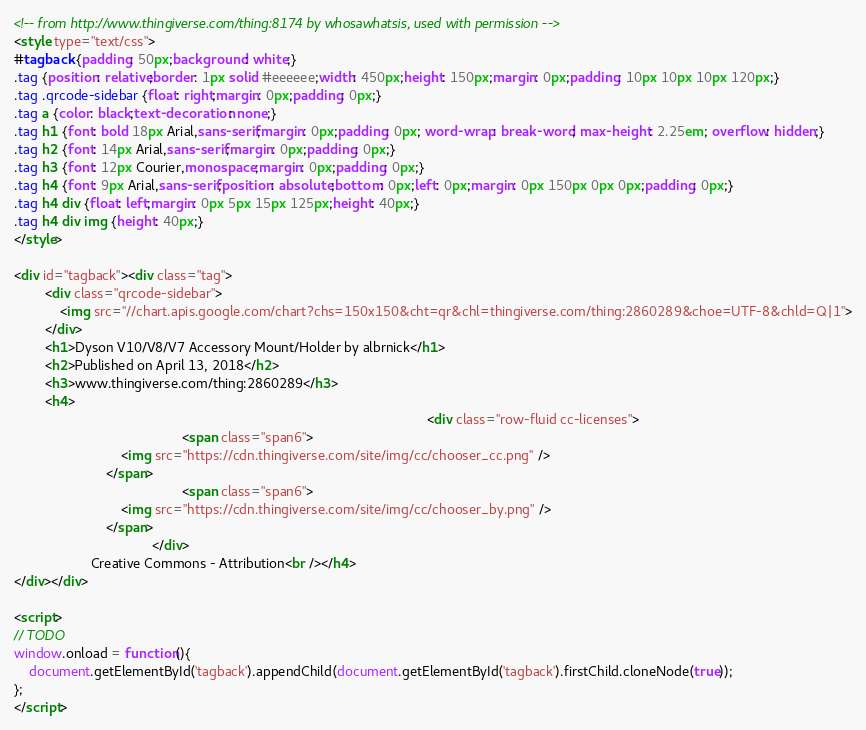Convert code to text. <code><loc_0><loc_0><loc_500><loc_500><_HTML_><!-- from http://www.thingiverse.com/thing:8174 by whosawhatsis, used with permission -->
<style type="text/css">
#tagback {padding: 50px;background: white;}
.tag {position: relative;border: 1px solid #eeeeee;width: 450px;height: 150px;margin: 0px;padding: 10px 10px 10px 120px;}
.tag .qrcode-sidebar {float: right;margin: 0px;padding: 0px;}
.tag a {color: black;text-decoration: none;}
.tag h1 {font: bold 18px Arial,sans-serif;margin: 0px;padding: 0px; word-wrap: break-word; max-height: 2.25em; overflow: hidden;}
.tag h2 {font: 14px Arial,sans-serif;margin: 0px;padding: 0px;}
.tag h3 {font: 12px Courier,monospace;margin: 0px;padding: 0px;}
.tag h4 {font: 9px Arial,sans-serif;position: absolute;bottom: 0px;left: 0px;margin: 0px 150px 0px 0px;padding: 0px;}
.tag h4 div {float: left;margin: 0px 5px 15px 125px;height: 40px;}
.tag h4 div img {height: 40px;}
</style>

<div id="tagback"><div class="tag">
        <div class="qrcode-sidebar">
            <img src="//chart.apis.google.com/chart?chs=150x150&cht=qr&chl=thingiverse.com/thing:2860289&choe=UTF-8&chld=Q|1">
        </div>
        <h1>Dyson V10/V8/V7 Accessory Mount/Holder by albrnick</h1>
        <h2>Published on April 13, 2018</h2>
        <h3>www.thingiverse.com/thing:2860289</h3>
        <h4>
                                                                                                            <div class="row-fluid cc-licenses">
                                            <span class="span6">
                            <img src="https://cdn.thingiverse.com/site/img/cc/chooser_cc.png" />
                        </span>
                                            <span class="span6">
                            <img src="https://cdn.thingiverse.com/site/img/cc/chooser_by.png" />
                        </span>
                                    </div>
                    Creative Commons - Attribution<br /></h4>
</div></div>

<script>
// TODO
window.onload = function(){
    document.getElementById('tagback').appendChild(document.getElementById('tagback').firstChild.cloneNode(true));
};
</script>
</code> 